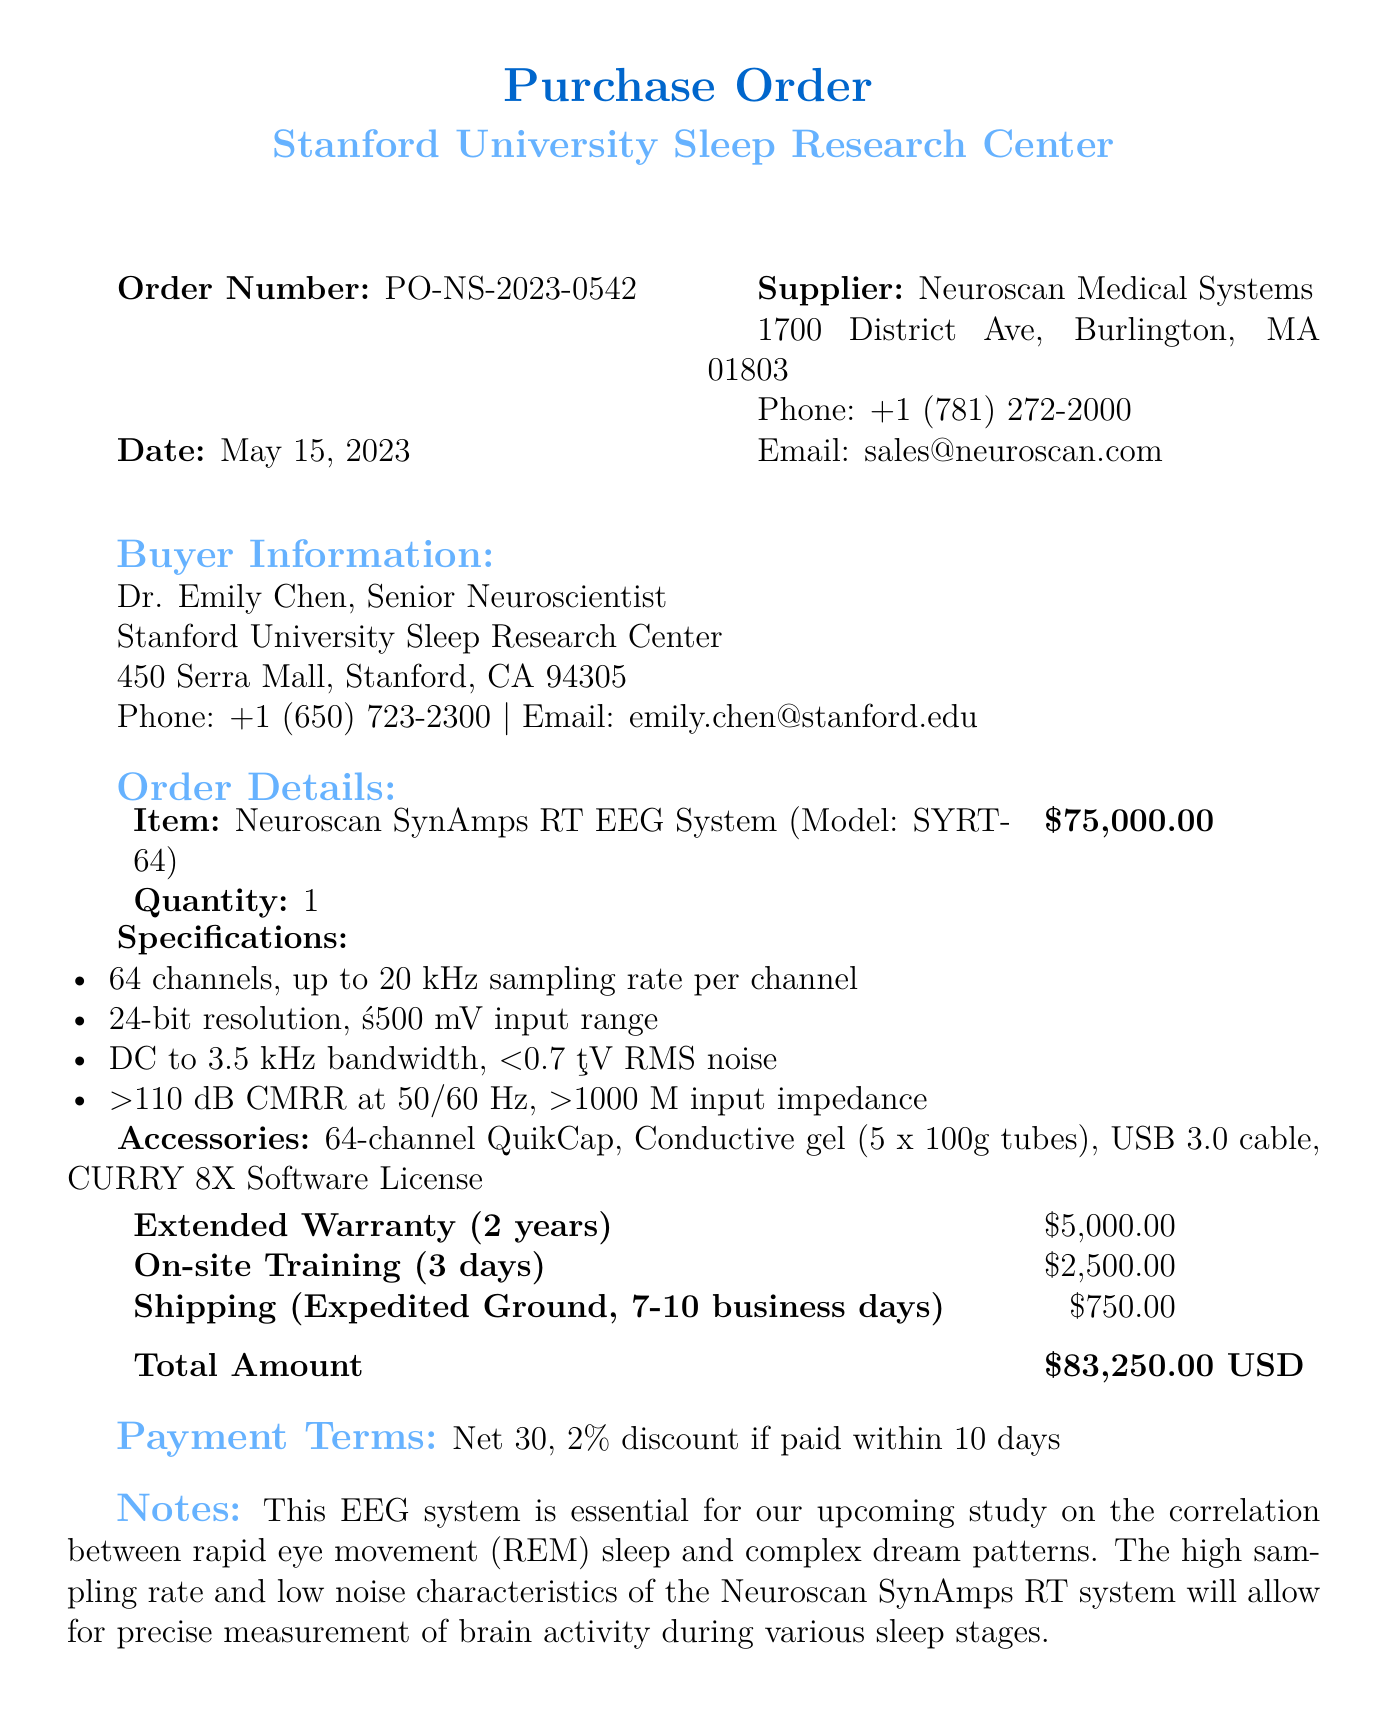What is the order number? The order number listed in the document is a unique identifier for the purchase, specifically "PO-NS-2023-0542".
Answer: PO-NS-2023-0542 Who is the buyer? The buyer's information identifies the individual making the purchase and is Dr. Emily Chen, who holds the title of Senior Neuroscientist.
Answer: Dr. Emily Chen What is the unit price of the EEG system? The unit price is explicitly stated for the Neuroscan SynAmps RT EEG System, which is $75,000.00.
Answer: $75,000.00 What is the duration of the extended warranty? The warranty specifies how long it lasts and in this case, it is for 2 years.
Answer: 2 years How much is the total amount due? The total amount reflects the overall cost of the purchase listed at the bottom of the document, which is $83,250.00.
Answer: $83,250.00 What shipping method is used? The document describes the shipping method selected for the purchase as "Expedited Ground".
Answer: Expedited Ground What is included in the accessories? The accessories listed provide additional items that come with the main purchase, including the "64-channel QuikCap" and others.
Answer: 64-channel QuikCap What are the payment terms? The payment terms detail the conditions for payment, specifically that it is "Net 30" with a discount clause.
Answer: Net 30 Why is the EEG system important for the study? The notes section highlights the significance of the EEG system for analyzing brain activity during sleep, especially related to REM sleep and dreams.
Answer: Essential for studying REM sleep and complex dream patterns 